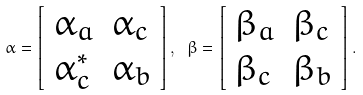Convert formula to latex. <formula><loc_0><loc_0><loc_500><loc_500>\alpha = \left [ \begin{array} { l l } \alpha _ { a } & \alpha _ { c } \\ \alpha _ { c } ^ { * } & \alpha _ { b } \end{array} \right ] , \text { } \beta = \left [ \begin{array} { l l } \beta _ { a } & \beta _ { c } \\ \beta _ { c } & \beta _ { b } \end{array} \right ] .</formula> 